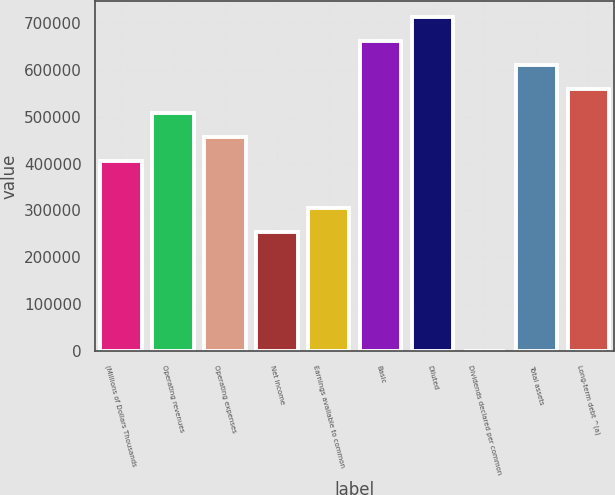Convert chart to OTSL. <chart><loc_0><loc_0><loc_500><loc_500><bar_chart><fcel>(Millions of Dollars Thousands<fcel>Operating revenues<fcel>Operating expenses<fcel>Net income<fcel>Earnings available to common<fcel>Basic<fcel>Diluted<fcel>Dividends declared per common<fcel>Total assets<fcel>Long-term debt ^(a)<nl><fcel>406535<fcel>508168<fcel>457351<fcel>254085<fcel>304901<fcel>660618<fcel>711435<fcel>1.28<fcel>609801<fcel>558985<nl></chart> 